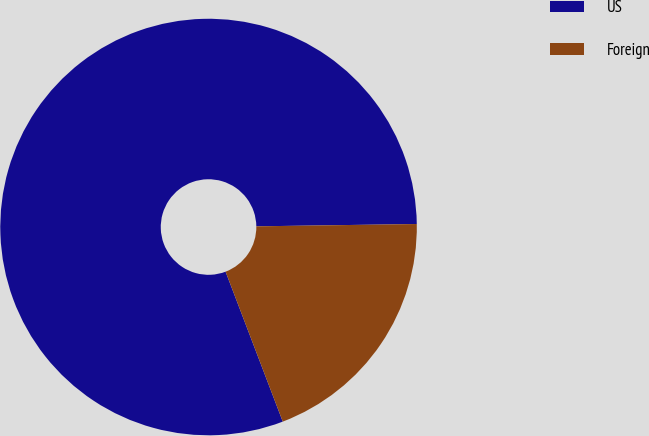<chart> <loc_0><loc_0><loc_500><loc_500><pie_chart><fcel>US<fcel>Foreign<nl><fcel>80.57%<fcel>19.43%<nl></chart> 